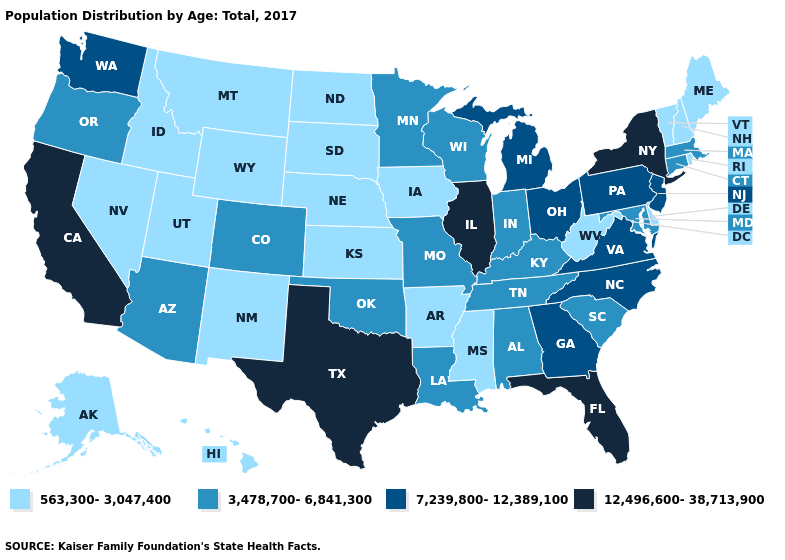Does Idaho have the highest value in the USA?
Be succinct. No. Which states have the highest value in the USA?
Keep it brief. California, Florida, Illinois, New York, Texas. What is the value of Wisconsin?
Write a very short answer. 3,478,700-6,841,300. Name the states that have a value in the range 3,478,700-6,841,300?
Short answer required. Alabama, Arizona, Colorado, Connecticut, Indiana, Kentucky, Louisiana, Maryland, Massachusetts, Minnesota, Missouri, Oklahoma, Oregon, South Carolina, Tennessee, Wisconsin. Does Idaho have the lowest value in the USA?
Be succinct. Yes. Name the states that have a value in the range 7,239,800-12,389,100?
Give a very brief answer. Georgia, Michigan, New Jersey, North Carolina, Ohio, Pennsylvania, Virginia, Washington. Among the states that border Maryland , does Delaware have the lowest value?
Be succinct. Yes. Does Ohio have a lower value than New York?
Keep it brief. Yes. Name the states that have a value in the range 7,239,800-12,389,100?
Concise answer only. Georgia, Michigan, New Jersey, North Carolina, Ohio, Pennsylvania, Virginia, Washington. What is the lowest value in the USA?
Be succinct. 563,300-3,047,400. What is the lowest value in the West?
Keep it brief. 563,300-3,047,400. Name the states that have a value in the range 3,478,700-6,841,300?
Concise answer only. Alabama, Arizona, Colorado, Connecticut, Indiana, Kentucky, Louisiana, Maryland, Massachusetts, Minnesota, Missouri, Oklahoma, Oregon, South Carolina, Tennessee, Wisconsin. Among the states that border New Hampshire , which have the highest value?
Quick response, please. Massachusetts. What is the value of Virginia?
Answer briefly. 7,239,800-12,389,100. Name the states that have a value in the range 563,300-3,047,400?
Give a very brief answer. Alaska, Arkansas, Delaware, Hawaii, Idaho, Iowa, Kansas, Maine, Mississippi, Montana, Nebraska, Nevada, New Hampshire, New Mexico, North Dakota, Rhode Island, South Dakota, Utah, Vermont, West Virginia, Wyoming. 